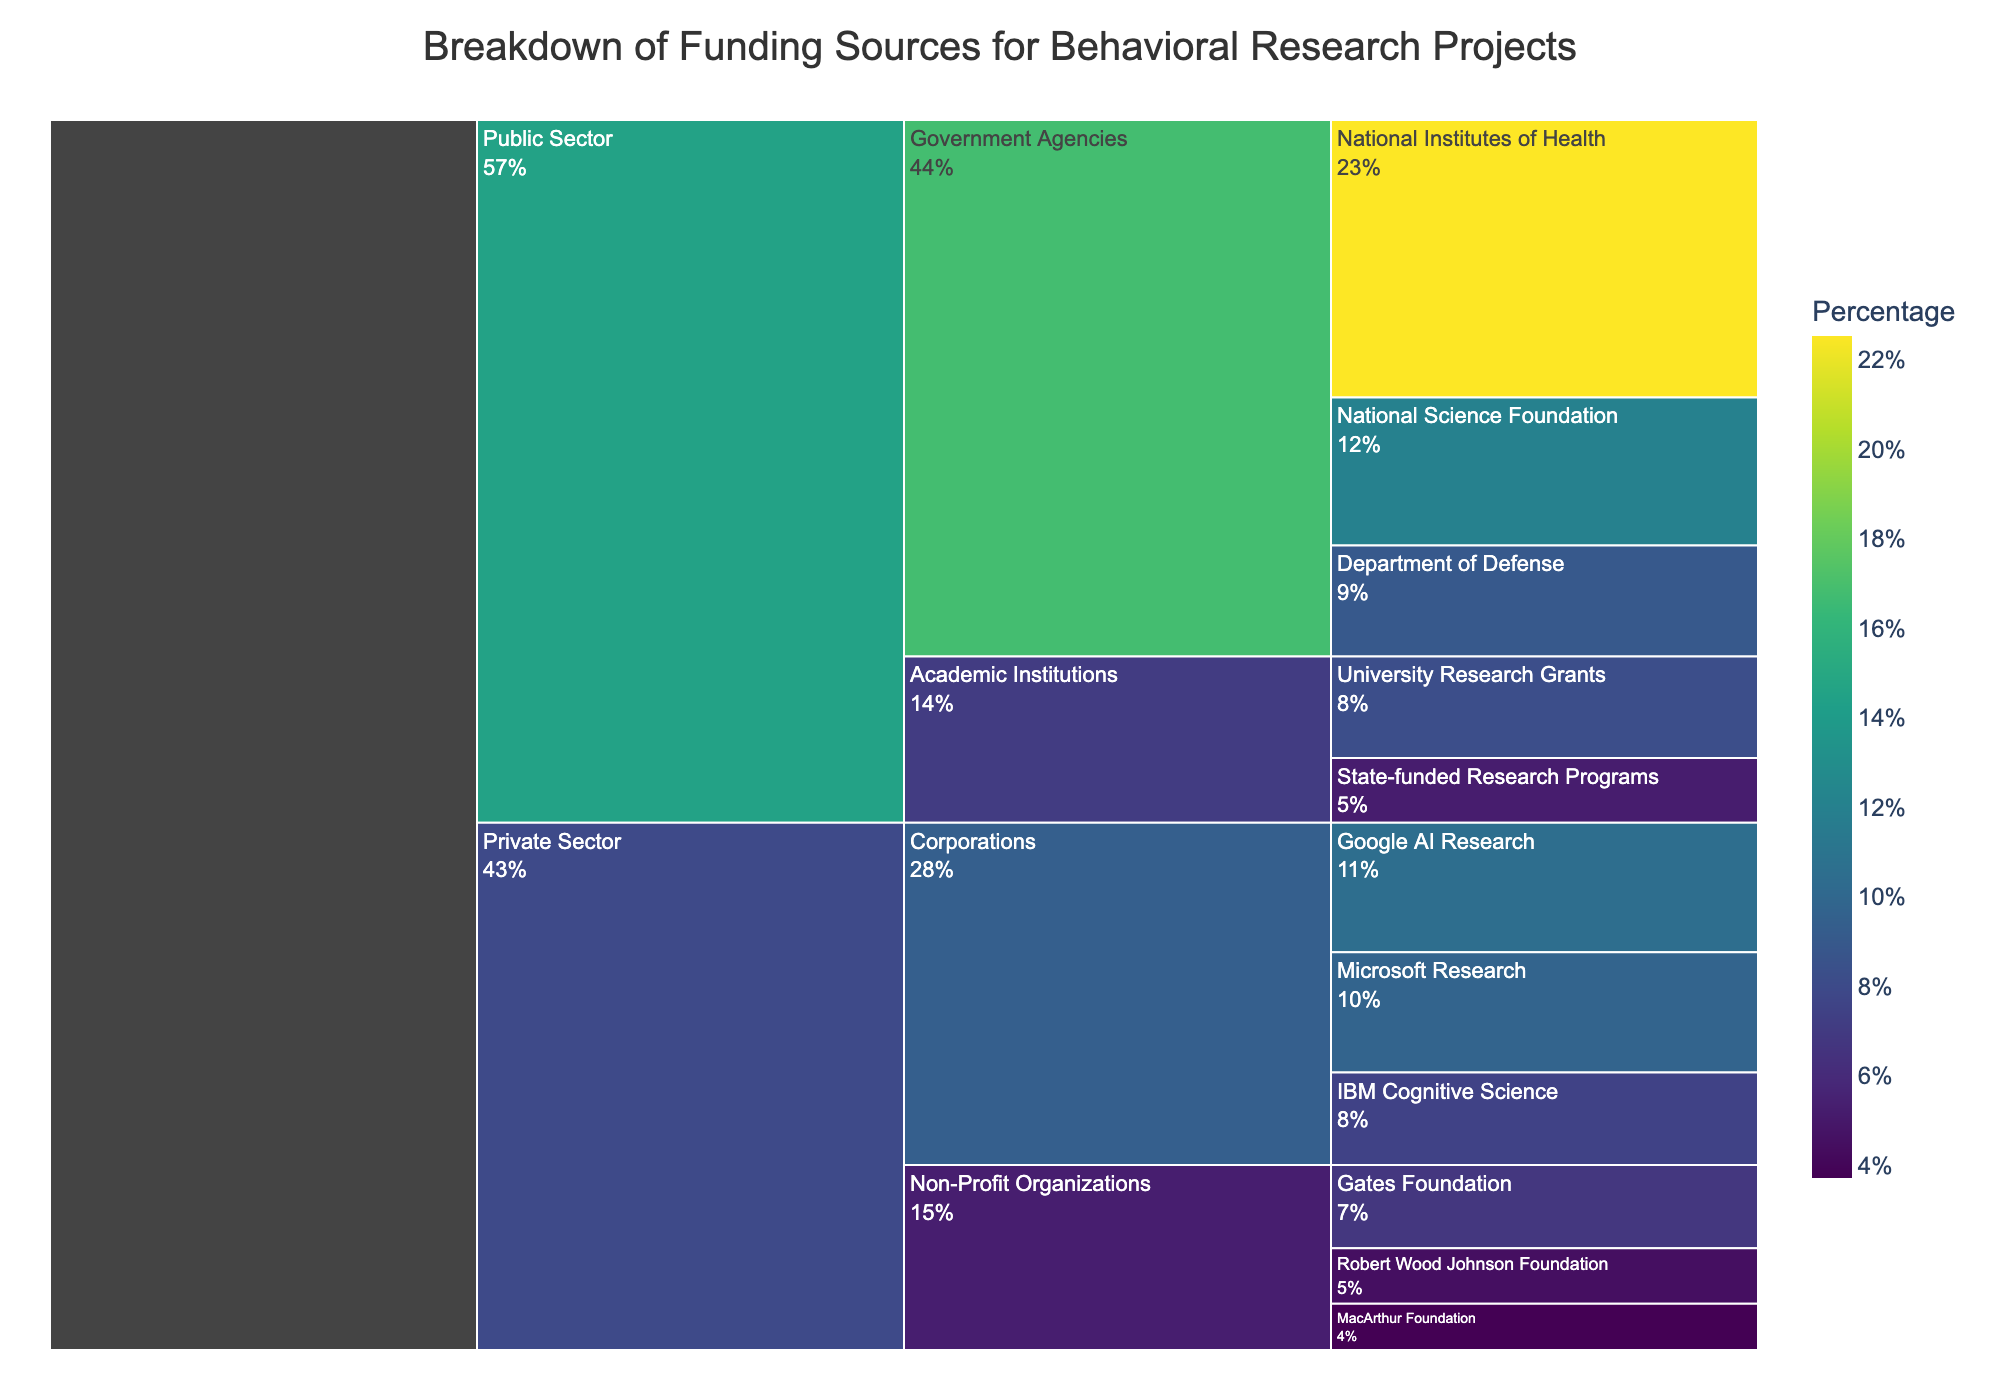What is the total amount of funding from Government Agencies? The Icicle Chart shows the breakdown of funding sources under "Public Sector" and "Government Agencies". Summing the amounts from National Institutes of Health, National Science Foundation, and Department of Defense gives the total. 15000000 + 8000000 + 6000000 = 29000000
Answer: 29000000 Which public sector subcategory received more funding, Academic Institutions or Government Agencies? Comparing the summed funding amounts for both subcategories: Government Agencies received 29000000, and Academic Institutions received 5500000 + 3500000 = 9000000. Therefore, Government Agencies received more funding.
Answer: Government Agencies What is the largest funding source in the Private Sector? Observing the breakdown under "Private Sector", the largest funding source listed is Google AI Research with 7000000.
Answer: Google AI Research How much more funding did Google AI Research receive compared to Microsoft Research? Google AI Research received 7000000 and Microsoft Research received 6500000. The difference between them is 7000000 - 6500000 = 500000.
Answer: 500000 What percentage of the total funding is contributed by the Gates Foundation? The total funding from all sources is summed up as 15000000 + 8000000 + 6000000 + 5500000 + 3500000 + 7000000 + 6500000 + 5000000 + 4500000 + 3000000 + 2500000 = 62800000. The Gates Foundation's contribution is 4500000. Calculating the percentage: (4500000 / 62800000) * 100 ≈ 7.2%.
Answer: 7.2% Which funding source in the Public Sector, Academic Institutions category, received the least funding? Under "Public Sector" and "Academic Institutions", we compare the funding amounts: University Research Grants received 5500000, and State-funded Research Programs received 3500000. Therefore, State-funded Research Programs received the least.
Answer: State-funded Research Programs How does the funding from Robert Wood Johnson Foundation compare to the funding from IBM Cognitive Science? Comparing the amounts: Robert Wood Johnson Foundation received 3000000, and IBM Cognitive Science received 5000000. IBM Cognitive Science received more funding.
Answer: IBM Cognitive Science What is the combined funding amount from the three major non-profit organizations listed in the Private Sector? Summing the amounts from Gates Foundation, Robert Wood Johnson Foundation, and MacArthur Foundation gives the total. 4500000 + 3000000 + 2500000 = 10000000
Answer: 10000000 How many subcategories are there in the Public Sector? From the Icicle Chart, under the "Public Sector" category, there are two subcategories: Government Agencies and Academic Institutions.
Answer: 2 What is the average funding amount per source within Government Agencies? Summing the amounts for National Institutes of Health, National Science Foundation, and Department of Defense gives 29000000. With each agency being a source, dividing 29000000 by 3 gives an average funding amount of 9666666.67.
Answer: 9666666.67 